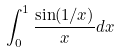<formula> <loc_0><loc_0><loc_500><loc_500>\int _ { 0 } ^ { 1 } \frac { \sin ( 1 / x ) } { x } d x</formula> 